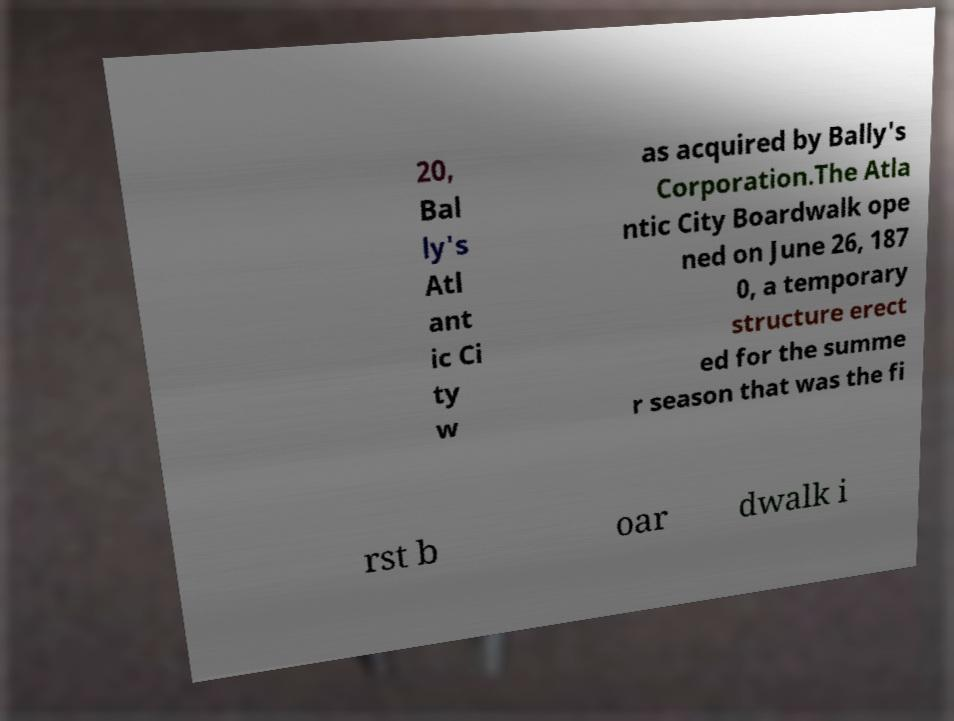Can you accurately transcribe the text from the provided image for me? 20, Bal ly's Atl ant ic Ci ty w as acquired by Bally's Corporation.The Atla ntic City Boardwalk ope ned on June 26, 187 0, a temporary structure erect ed for the summe r season that was the fi rst b oar dwalk i 